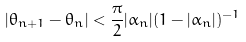Convert formula to latex. <formula><loc_0><loc_0><loc_500><loc_500>| \theta _ { n + 1 } - \theta _ { n } | < \frac { \pi } { 2 } | \alpha _ { n } | ( 1 - | \alpha _ { n } | ) ^ { - 1 }</formula> 